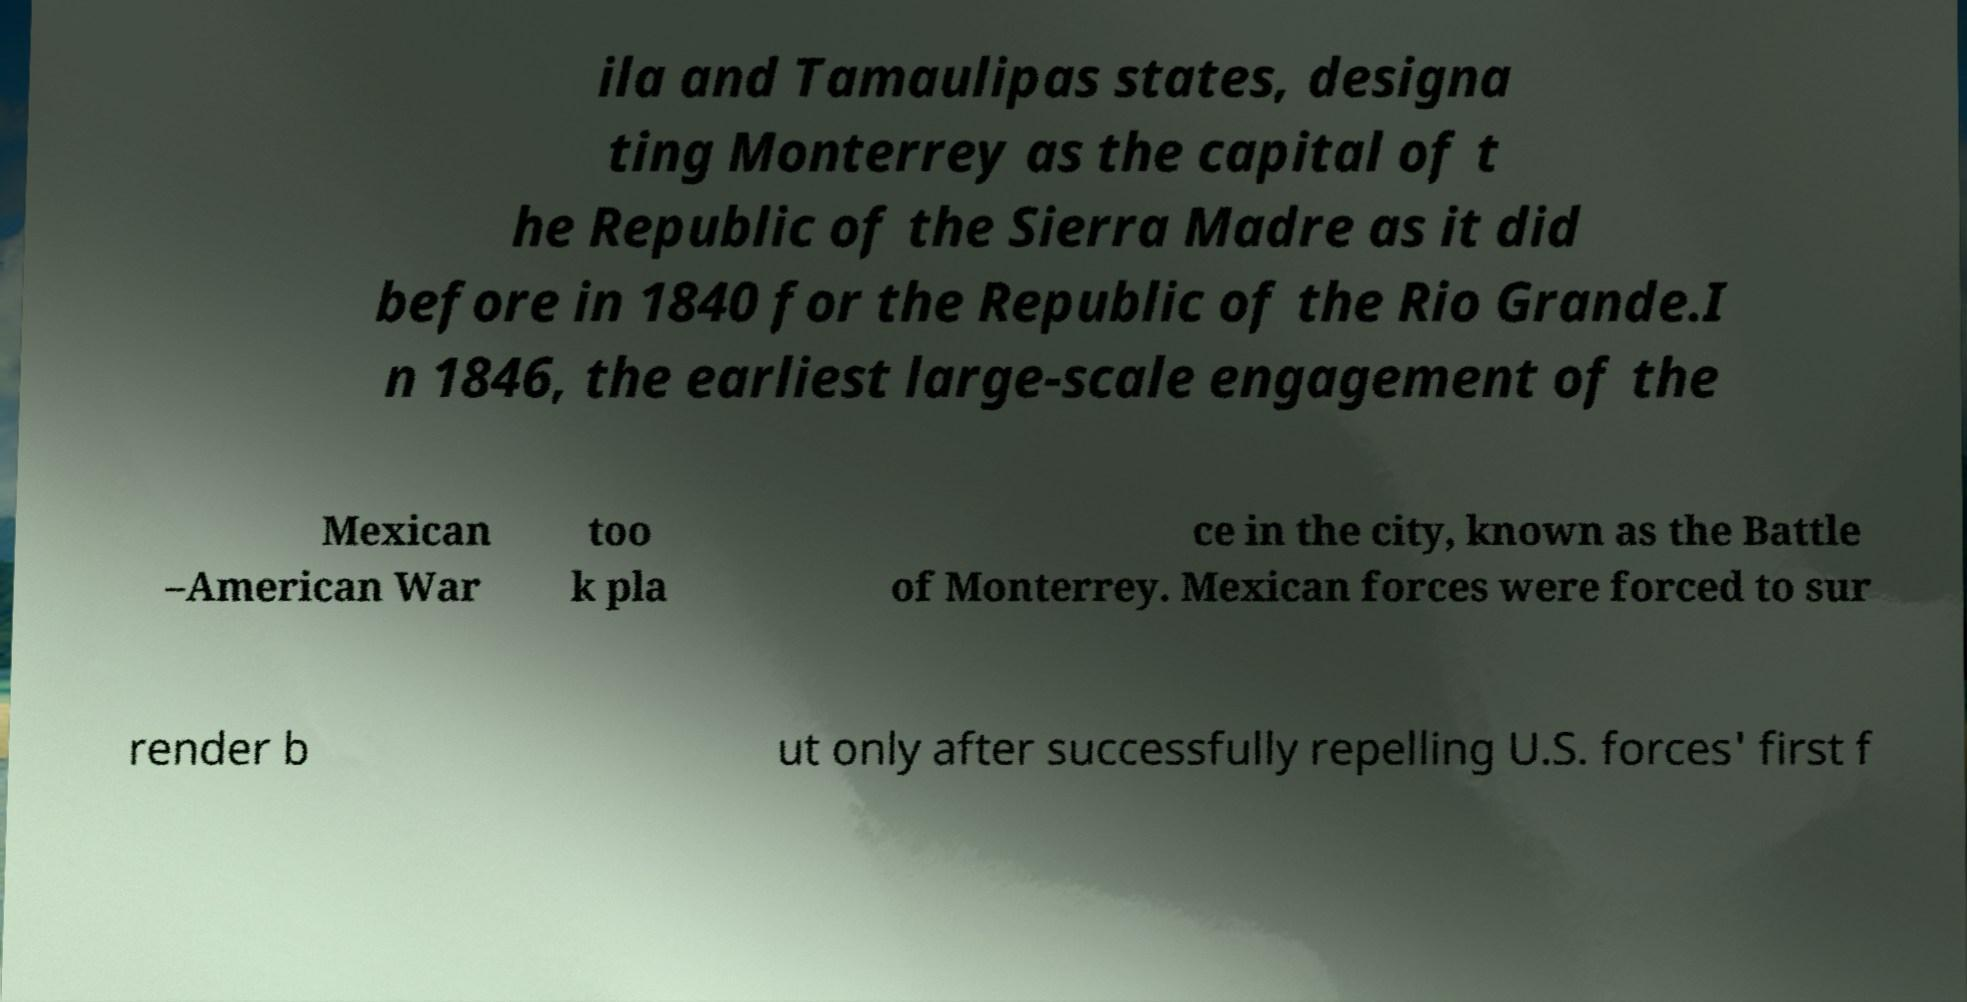Please identify and transcribe the text found in this image. ila and Tamaulipas states, designa ting Monterrey as the capital of t he Republic of the Sierra Madre as it did before in 1840 for the Republic of the Rio Grande.I n 1846, the earliest large-scale engagement of the Mexican –American War too k pla ce in the city, known as the Battle of Monterrey. Mexican forces were forced to sur render b ut only after successfully repelling U.S. forces' first f 